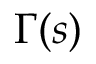<formula> <loc_0><loc_0><loc_500><loc_500>\Gamma ( s )</formula> 